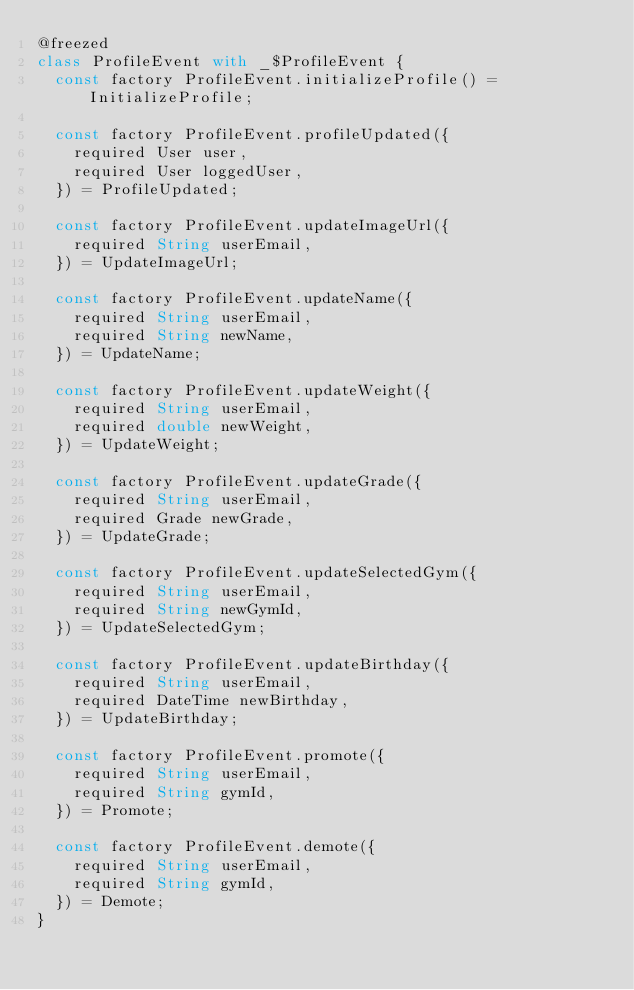<code> <loc_0><loc_0><loc_500><loc_500><_Dart_>@freezed
class ProfileEvent with _$ProfileEvent {
  const factory ProfileEvent.initializeProfile() = InitializeProfile;

  const factory ProfileEvent.profileUpdated({
    required User user,
    required User loggedUser,
  }) = ProfileUpdated;

  const factory ProfileEvent.updateImageUrl({
    required String userEmail,
  }) = UpdateImageUrl;

  const factory ProfileEvent.updateName({
    required String userEmail,
    required String newName,
  }) = UpdateName;

  const factory ProfileEvent.updateWeight({
    required String userEmail,
    required double newWeight,
  }) = UpdateWeight;

  const factory ProfileEvent.updateGrade({
    required String userEmail,
    required Grade newGrade,
  }) = UpdateGrade;

  const factory ProfileEvent.updateSelectedGym({
    required String userEmail,
    required String newGymId,
  }) = UpdateSelectedGym;

  const factory ProfileEvent.updateBirthday({
    required String userEmail,
    required DateTime newBirthday,
  }) = UpdateBirthday;

  const factory ProfileEvent.promote({
    required String userEmail,
    required String gymId,
  }) = Promote;

  const factory ProfileEvent.demote({
    required String userEmail,
    required String gymId,
  }) = Demote;
}
</code> 